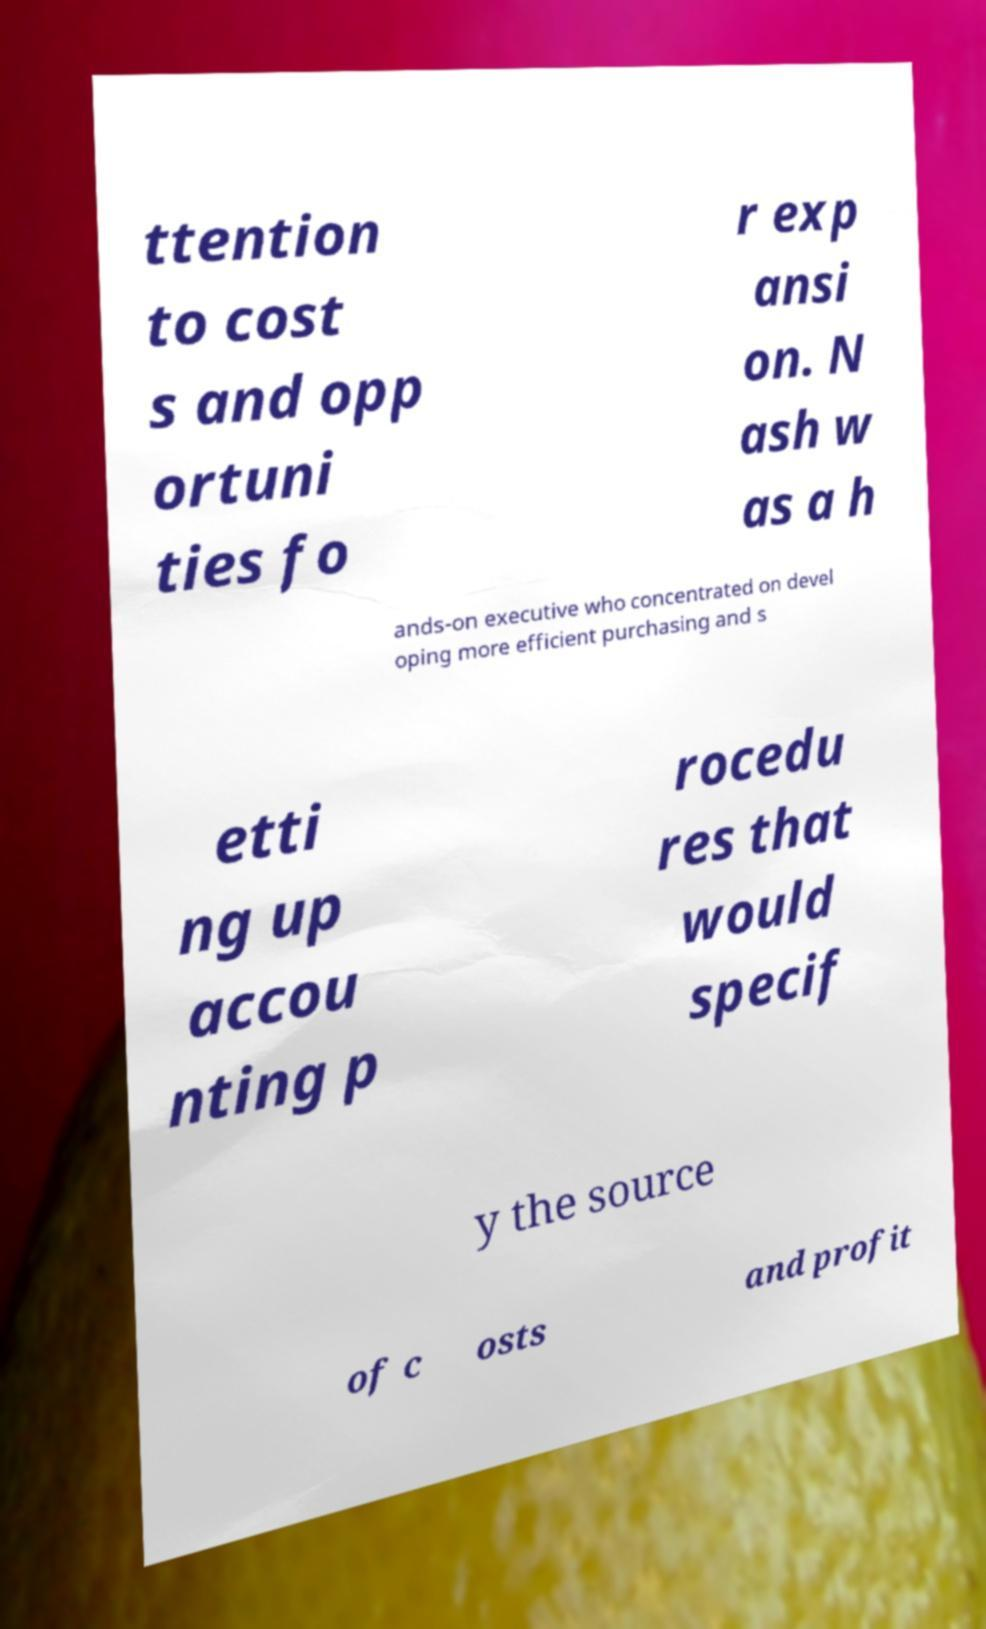Could you extract and type out the text from this image? ttention to cost s and opp ortuni ties fo r exp ansi on. N ash w as a h ands-on executive who concentrated on devel oping more efficient purchasing and s etti ng up accou nting p rocedu res that would specif y the source of c osts and profit 